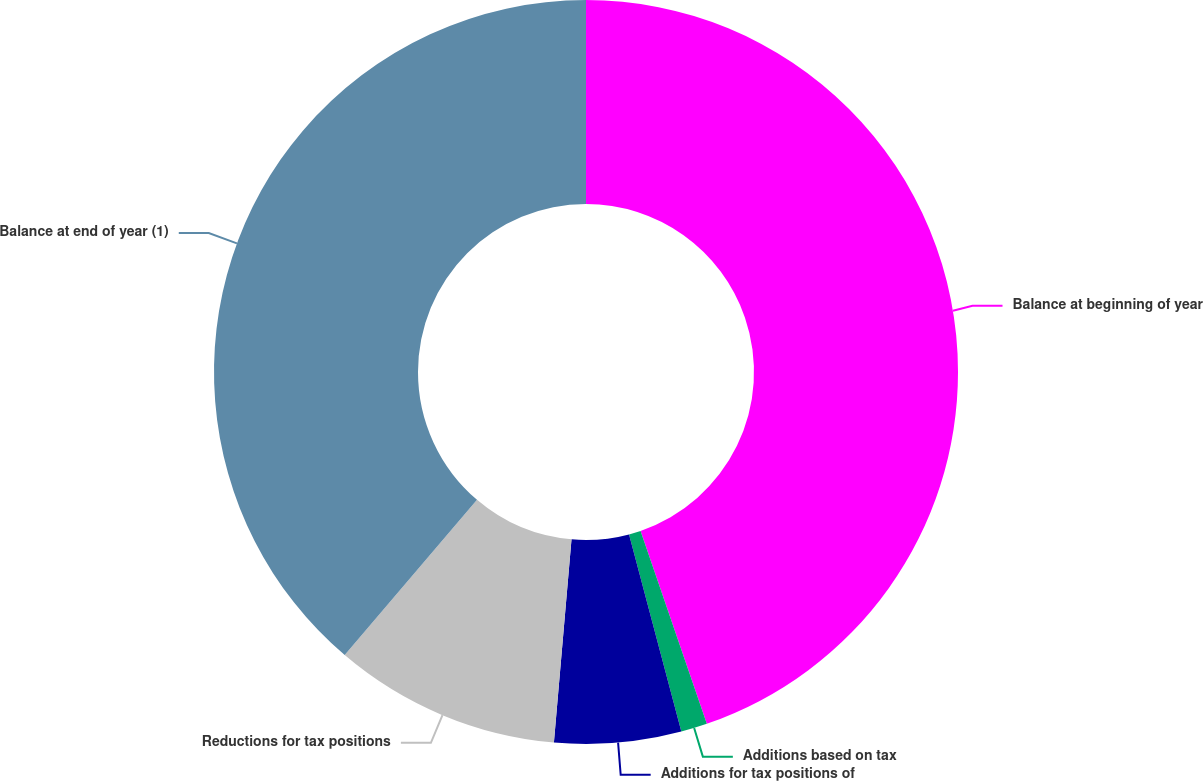Convert chart to OTSL. <chart><loc_0><loc_0><loc_500><loc_500><pie_chart><fcel>Balance at beginning of year<fcel>Additions based on tax<fcel>Additions for tax positions of<fcel>Reductions for tax positions<fcel>Balance at end of year (1)<nl><fcel>44.74%<fcel>1.14%<fcel>5.5%<fcel>9.86%<fcel>38.77%<nl></chart> 